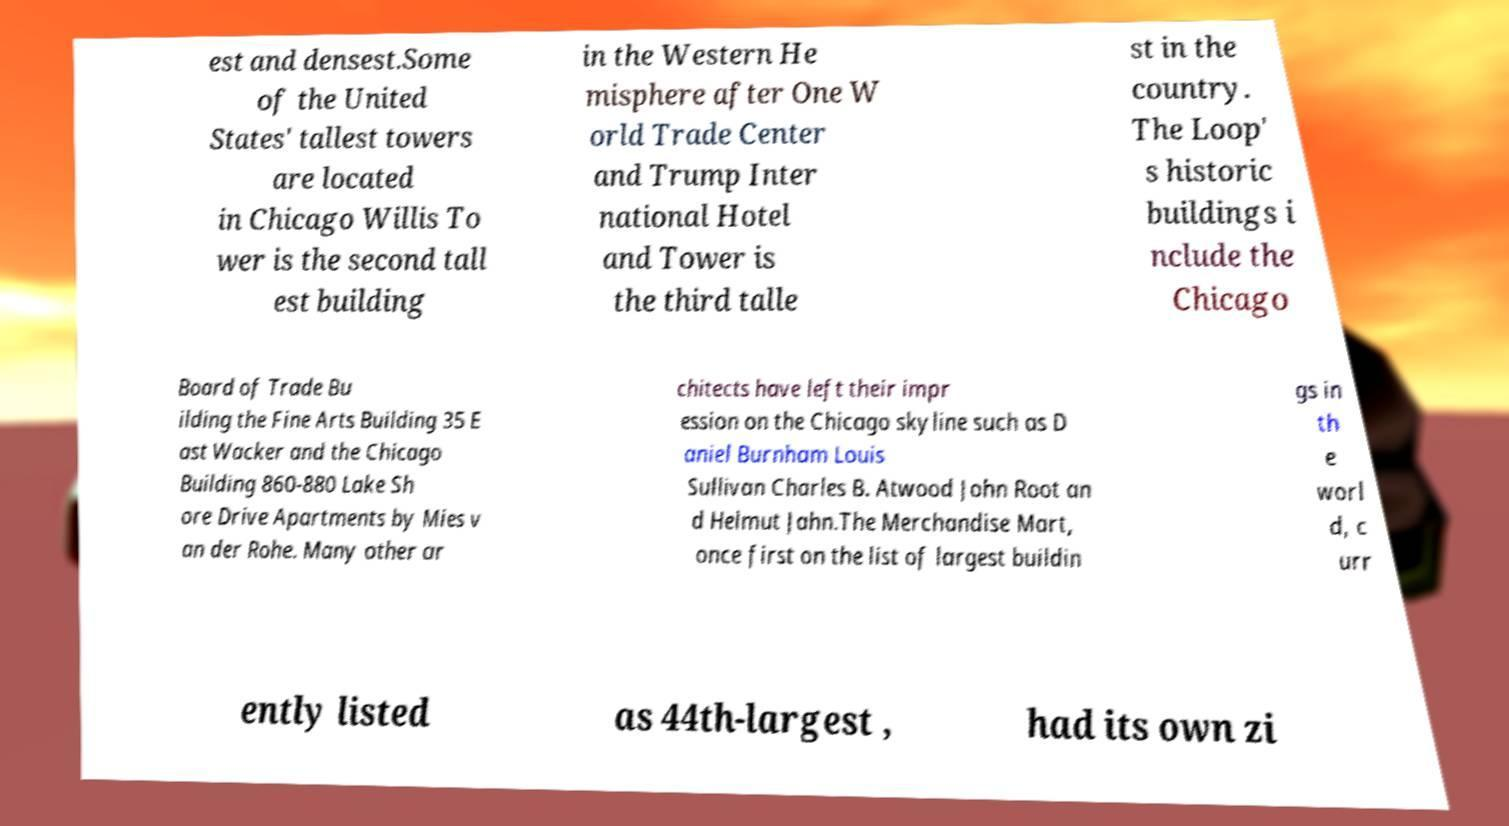Please read and relay the text visible in this image. What does it say? est and densest.Some of the United States' tallest towers are located in Chicago Willis To wer is the second tall est building in the Western He misphere after One W orld Trade Center and Trump Inter national Hotel and Tower is the third talle st in the country. The Loop' s historic buildings i nclude the Chicago Board of Trade Bu ilding the Fine Arts Building 35 E ast Wacker and the Chicago Building 860-880 Lake Sh ore Drive Apartments by Mies v an der Rohe. Many other ar chitects have left their impr ession on the Chicago skyline such as D aniel Burnham Louis Sullivan Charles B. Atwood John Root an d Helmut Jahn.The Merchandise Mart, once first on the list of largest buildin gs in th e worl d, c urr ently listed as 44th-largest , had its own zi 